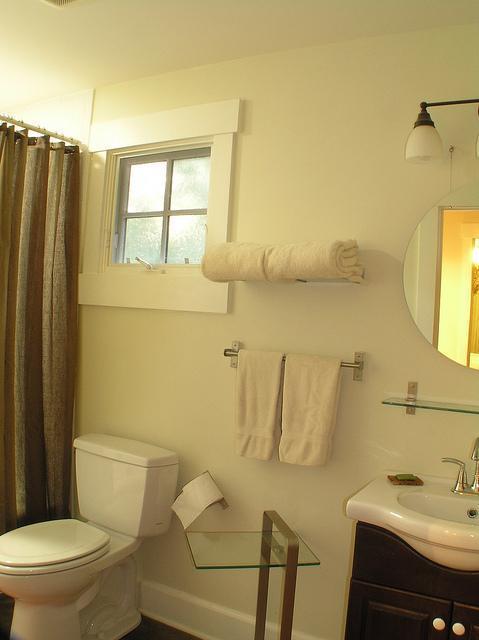How many robes are hanging up?
Give a very brief answer. 0. 